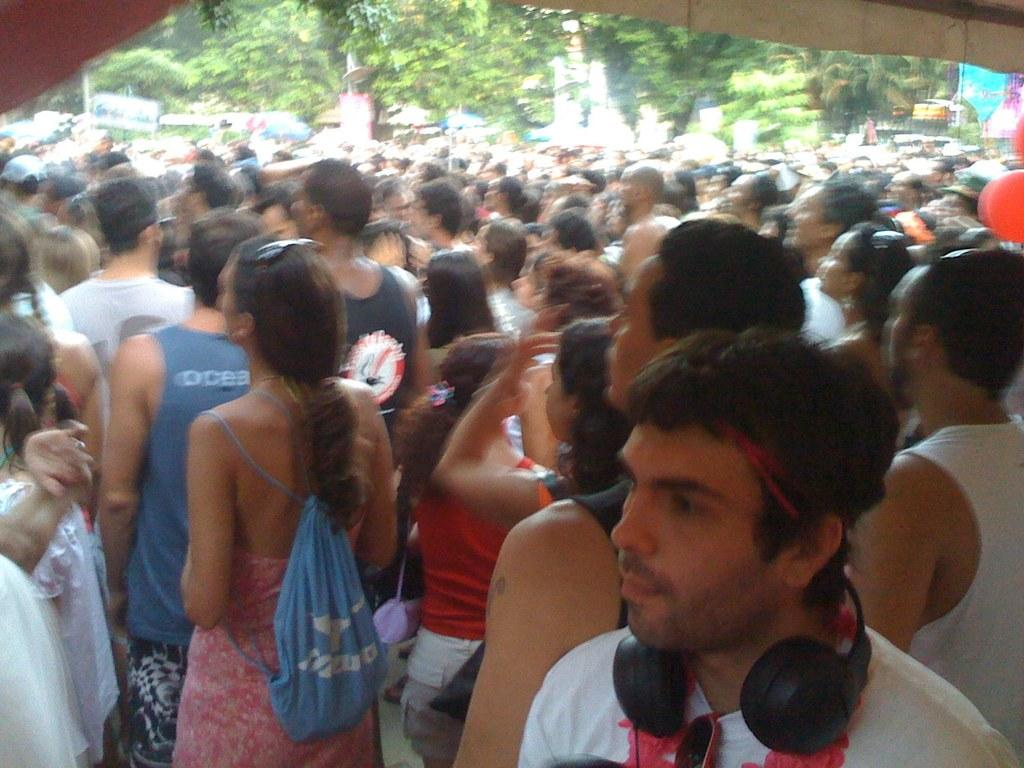What is the main subject of the image? The main subject of the image is a crowd. What can be seen in the background of the image? There are trees in the image. What objects are present in the image besides the crowd? There are boards and balloons in the image. What type of trucks can be seen in the image? There are no trucks present in the image. What is the crowd offering to the people in the image? The crowd is not offering anything to the people in the image; there is no indication of an exchange or interaction. 